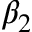<formula> <loc_0><loc_0><loc_500><loc_500>\beta _ { 2 }</formula> 